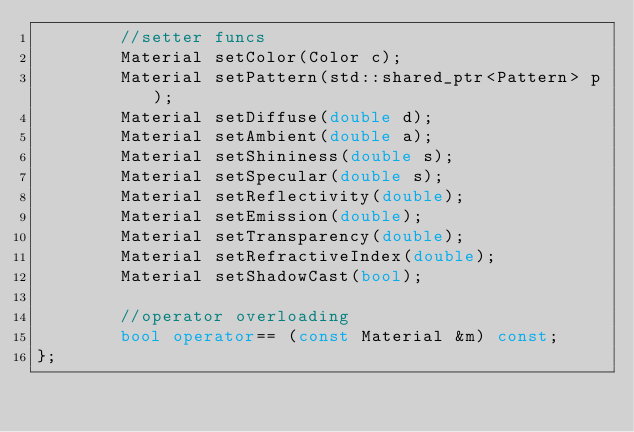<code> <loc_0><loc_0><loc_500><loc_500><_C++_>        //setter funcs
        Material setColor(Color c);
        Material setPattern(std::shared_ptr<Pattern> p);
        Material setDiffuse(double d);
        Material setAmbient(double a);
        Material setShininess(double s);
        Material setSpecular(double s);
        Material setReflectivity(double);
        Material setEmission(double);
        Material setTransparency(double);
        Material setRefractiveIndex(double);
        Material setShadowCast(bool);

        //operator overloading
        bool operator== (const Material &m) const;
};
</code> 